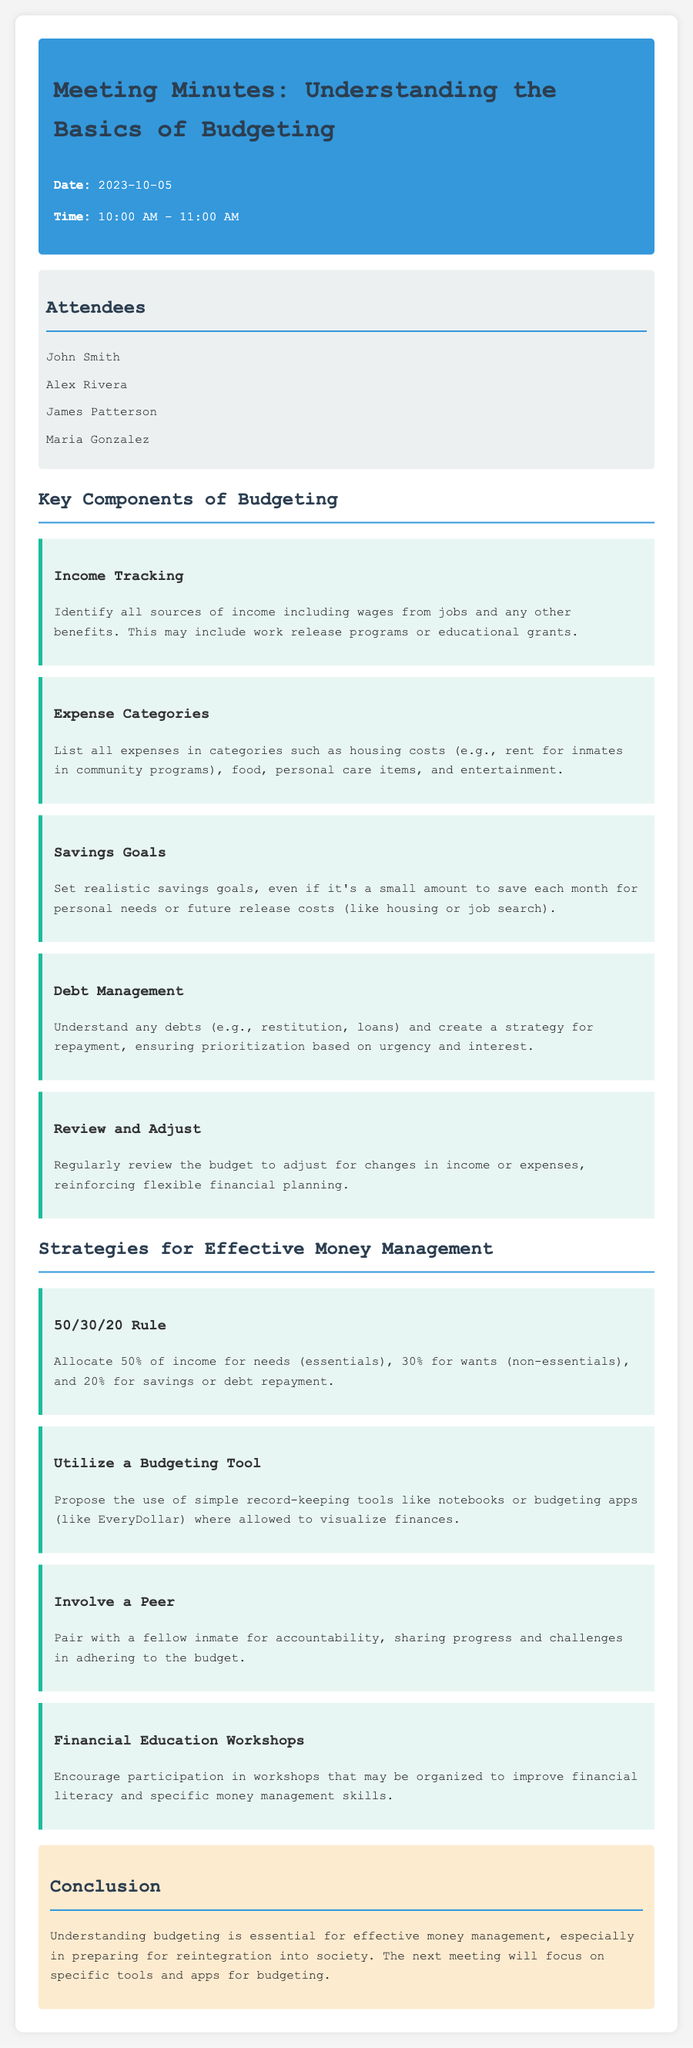What was the date of the meeting? The date of the meeting is explicitly mentioned in the document.
Answer: 2023-10-05 Who was one of the attendees? The document lists several attendees, providing their names.
Answer: John Smith What is one category of expenses mentioned? The document outlines specific categories of expenses that need to be tracked for budgeting.
Answer: Housing costs What should savings goals be like? The document gives guidance on the nature of savings goals in the context of budgeting.
Answer: Realistic What is the 50/30/20 Rule? The document defines a specific budgeting strategy known as the 50/30/20 Rule.
Answer: Allocate 50% for needs, 30% for wants, and 20% for savings What is one proposed budgeting tool? The meeting minutes highlight tools that can be used for effective budgeting.
Answer: Budgeting apps What is a suggested strategy for accountability? The document provides a recommendation for increasing adherence to budgeting efforts by leveraging support.
Answer: Involve a Peer What is the main focus of the next meeting? The conclusion section specifies what the next meeting will address regarding budgeting.
Answer: Specific tools and apps for budgeting 